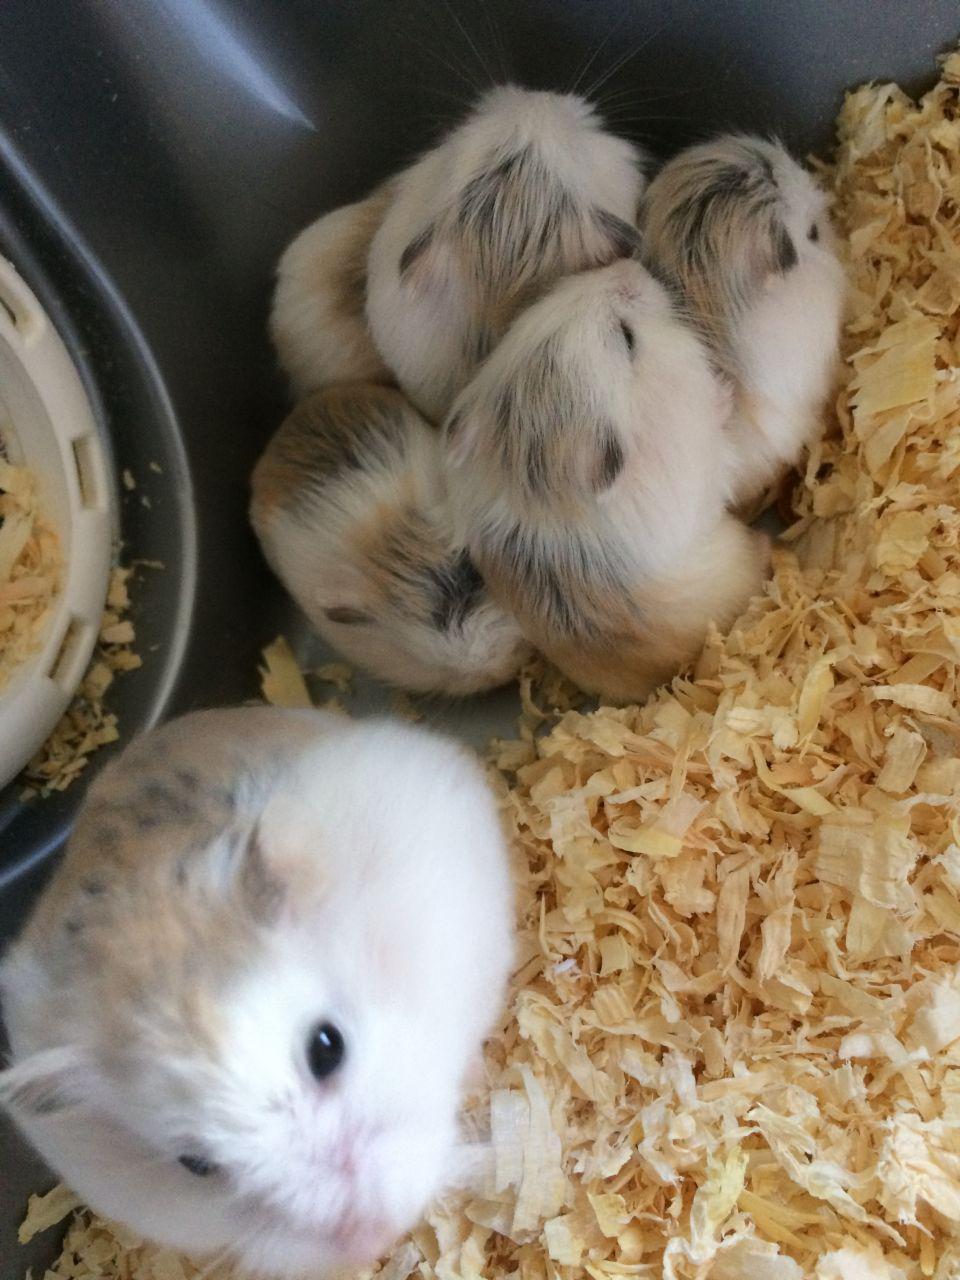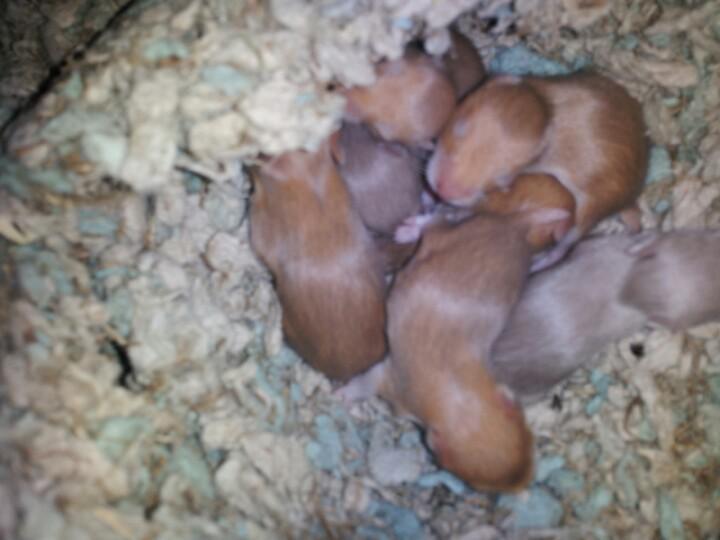The first image is the image on the left, the second image is the image on the right. Analyze the images presented: Is the assertion "An image contains at least one blackish newborn rodent." valid? Answer yes or no. No. The first image is the image on the left, the second image is the image on the right. Evaluate the accuracy of this statement regarding the images: "At least one mouse has it's eyes wide open and and least one mouse is sleeping.". Is it true? Answer yes or no. Yes. 